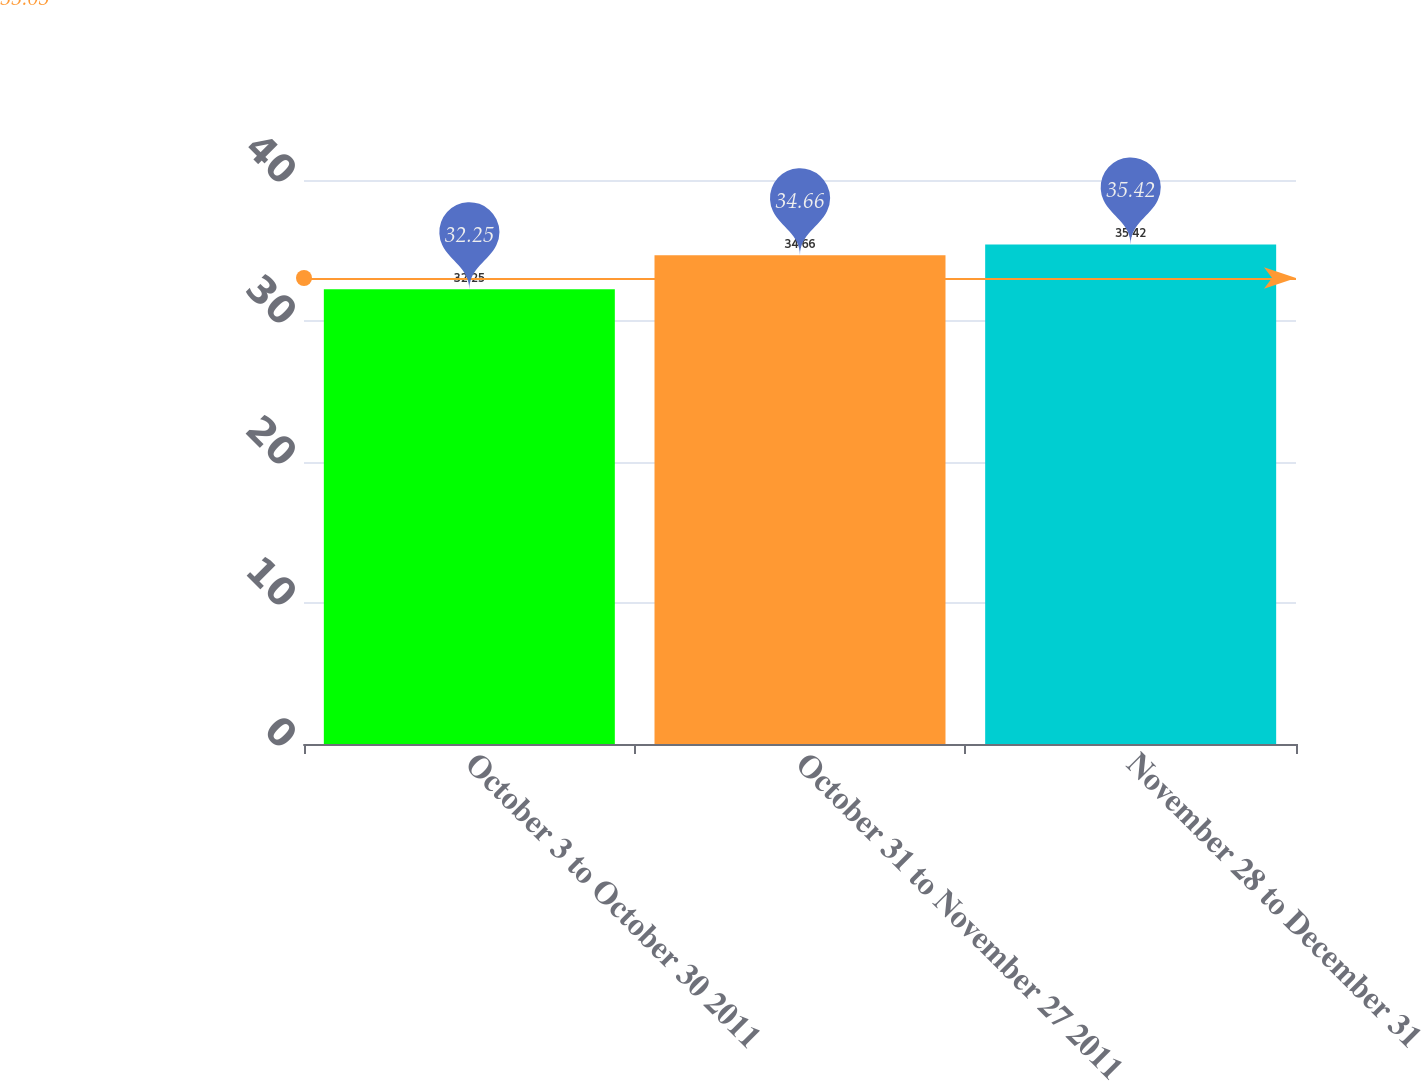Convert chart to OTSL. <chart><loc_0><loc_0><loc_500><loc_500><bar_chart><fcel>October 3 to October 30 2011<fcel>October 31 to November 27 2011<fcel>November 28 to December 31<nl><fcel>32.25<fcel>34.66<fcel>35.42<nl></chart> 